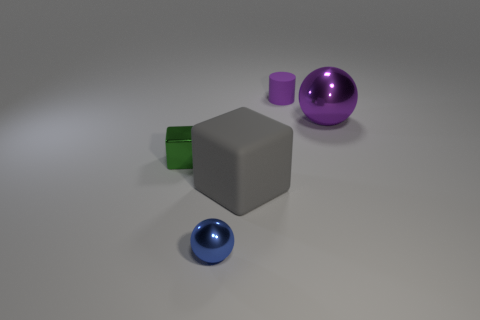There is a big sphere that is the same color as the tiny matte thing; what material is it?
Your answer should be compact. Metal. The thing on the left side of the tiny metallic thing in front of the small green block is what shape?
Your answer should be very brief. Cube. Are there any other tiny purple things of the same shape as the small purple thing?
Provide a short and direct response. No. How many small metallic cylinders are there?
Offer a very short reply. 0. Do the purple object on the right side of the tiny cylinder and the gray block have the same material?
Offer a terse response. No. Are there any metal things that have the same size as the shiny cube?
Give a very brief answer. Yes. There is a small rubber thing; is it the same shape as the big object that is to the left of the tiny cylinder?
Offer a terse response. No. There is a thing that is on the left side of the tiny metallic object in front of the metal cube; is there a tiny shiny cube on the left side of it?
Your response must be concise. No. How big is the blue shiny sphere?
Keep it short and to the point. Small. What number of other things are the same color as the tiny shiny sphere?
Provide a short and direct response. 0. 